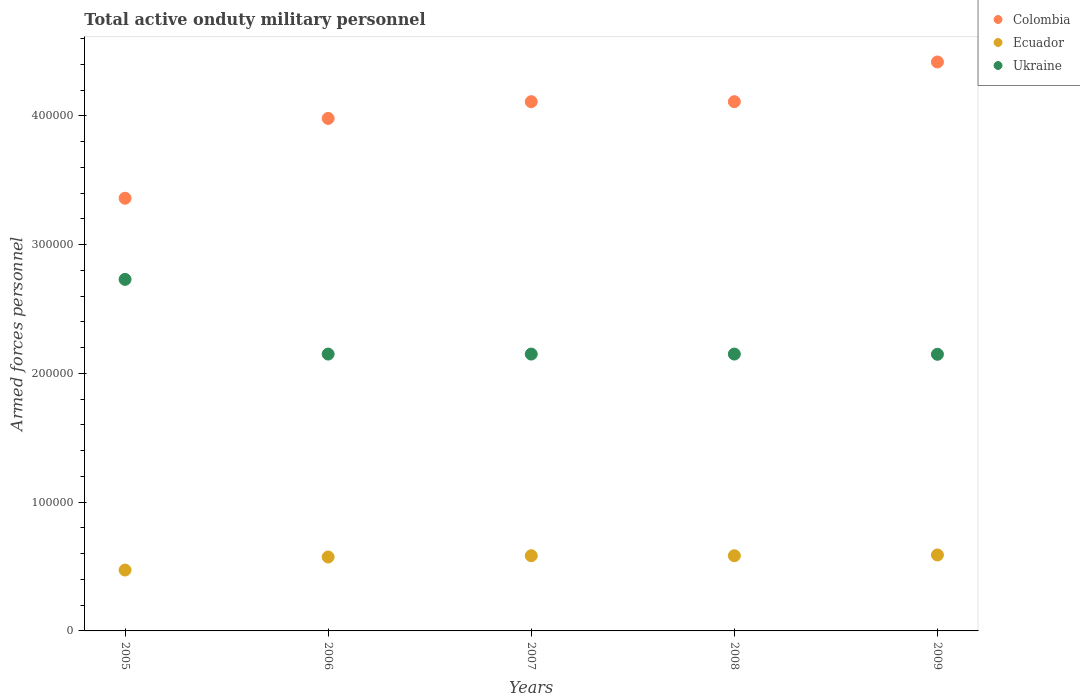Is the number of dotlines equal to the number of legend labels?
Give a very brief answer. Yes. What is the number of armed forces personnel in Ukraine in 2006?
Provide a succinct answer. 2.15e+05. Across all years, what is the maximum number of armed forces personnel in Ukraine?
Ensure brevity in your answer.  2.73e+05. Across all years, what is the minimum number of armed forces personnel in Ukraine?
Offer a terse response. 2.15e+05. What is the total number of armed forces personnel in Ecuador in the graph?
Offer a terse response. 2.80e+05. What is the difference between the number of armed forces personnel in Ecuador in 2006 and that in 2007?
Your answer should be very brief. -1000. What is the difference between the number of armed forces personnel in Colombia in 2005 and the number of armed forces personnel in Ecuador in 2009?
Ensure brevity in your answer.  2.77e+05. What is the average number of armed forces personnel in Ecuador per year?
Provide a succinct answer. 5.61e+04. In the year 2008, what is the difference between the number of armed forces personnel in Colombia and number of armed forces personnel in Ecuador?
Ensure brevity in your answer.  3.53e+05. What is the ratio of the number of armed forces personnel in Ukraine in 2006 to that in 2008?
Provide a short and direct response. 1. What is the difference between the highest and the second highest number of armed forces personnel in Ukraine?
Offer a terse response. 5.80e+04. What is the difference between the highest and the lowest number of armed forces personnel in Colombia?
Keep it short and to the point. 1.06e+05. Is the sum of the number of armed forces personnel in Ukraine in 2006 and 2009 greater than the maximum number of armed forces personnel in Ecuador across all years?
Give a very brief answer. Yes. Is it the case that in every year, the sum of the number of armed forces personnel in Ukraine and number of armed forces personnel in Ecuador  is greater than the number of armed forces personnel in Colombia?
Offer a terse response. No. Does the number of armed forces personnel in Colombia monotonically increase over the years?
Ensure brevity in your answer.  No. Is the number of armed forces personnel in Ecuador strictly less than the number of armed forces personnel in Colombia over the years?
Keep it short and to the point. Yes. How many years are there in the graph?
Give a very brief answer. 5. Are the values on the major ticks of Y-axis written in scientific E-notation?
Your answer should be compact. No. Does the graph contain any zero values?
Ensure brevity in your answer.  No. Does the graph contain grids?
Ensure brevity in your answer.  No. Where does the legend appear in the graph?
Give a very brief answer. Top right. What is the title of the graph?
Your response must be concise. Total active onduty military personnel. Does "Sudan" appear as one of the legend labels in the graph?
Your answer should be very brief. No. What is the label or title of the Y-axis?
Provide a short and direct response. Armed forces personnel. What is the Armed forces personnel in Colombia in 2005?
Give a very brief answer. 3.36e+05. What is the Armed forces personnel in Ecuador in 2005?
Your response must be concise. 4.73e+04. What is the Armed forces personnel of Ukraine in 2005?
Your answer should be compact. 2.73e+05. What is the Armed forces personnel of Colombia in 2006?
Provide a short and direct response. 3.98e+05. What is the Armed forces personnel of Ecuador in 2006?
Provide a succinct answer. 5.74e+04. What is the Armed forces personnel of Ukraine in 2006?
Ensure brevity in your answer.  2.15e+05. What is the Armed forces personnel of Colombia in 2007?
Provide a succinct answer. 4.11e+05. What is the Armed forces personnel in Ecuador in 2007?
Provide a succinct answer. 5.84e+04. What is the Armed forces personnel in Ukraine in 2007?
Provide a short and direct response. 2.15e+05. What is the Armed forces personnel of Colombia in 2008?
Give a very brief answer. 4.11e+05. What is the Armed forces personnel in Ecuador in 2008?
Offer a terse response. 5.84e+04. What is the Armed forces personnel in Ukraine in 2008?
Keep it short and to the point. 2.15e+05. What is the Armed forces personnel of Colombia in 2009?
Provide a succinct answer. 4.42e+05. What is the Armed forces personnel in Ecuador in 2009?
Offer a very short reply. 5.90e+04. What is the Armed forces personnel in Ukraine in 2009?
Your response must be concise. 2.15e+05. Across all years, what is the maximum Armed forces personnel of Colombia?
Your response must be concise. 4.42e+05. Across all years, what is the maximum Armed forces personnel of Ecuador?
Ensure brevity in your answer.  5.90e+04. Across all years, what is the maximum Armed forces personnel of Ukraine?
Ensure brevity in your answer.  2.73e+05. Across all years, what is the minimum Armed forces personnel of Colombia?
Your answer should be compact. 3.36e+05. Across all years, what is the minimum Armed forces personnel in Ecuador?
Keep it short and to the point. 4.73e+04. Across all years, what is the minimum Armed forces personnel of Ukraine?
Keep it short and to the point. 2.15e+05. What is the total Armed forces personnel of Colombia in the graph?
Provide a short and direct response. 2.00e+06. What is the total Armed forces personnel of Ecuador in the graph?
Make the answer very short. 2.80e+05. What is the total Armed forces personnel of Ukraine in the graph?
Make the answer very short. 1.13e+06. What is the difference between the Armed forces personnel in Colombia in 2005 and that in 2006?
Offer a very short reply. -6.20e+04. What is the difference between the Armed forces personnel of Ecuador in 2005 and that in 2006?
Make the answer very short. -1.01e+04. What is the difference between the Armed forces personnel in Ukraine in 2005 and that in 2006?
Give a very brief answer. 5.80e+04. What is the difference between the Armed forces personnel in Colombia in 2005 and that in 2007?
Keep it short and to the point. -7.50e+04. What is the difference between the Armed forces personnel in Ecuador in 2005 and that in 2007?
Your answer should be very brief. -1.11e+04. What is the difference between the Armed forces personnel in Ukraine in 2005 and that in 2007?
Your response must be concise. 5.80e+04. What is the difference between the Armed forces personnel in Colombia in 2005 and that in 2008?
Keep it short and to the point. -7.50e+04. What is the difference between the Armed forces personnel of Ecuador in 2005 and that in 2008?
Make the answer very short. -1.11e+04. What is the difference between the Armed forces personnel in Ukraine in 2005 and that in 2008?
Give a very brief answer. 5.80e+04. What is the difference between the Armed forces personnel in Colombia in 2005 and that in 2009?
Provide a short and direct response. -1.06e+05. What is the difference between the Armed forces personnel in Ecuador in 2005 and that in 2009?
Ensure brevity in your answer.  -1.17e+04. What is the difference between the Armed forces personnel in Ukraine in 2005 and that in 2009?
Provide a succinct answer. 5.82e+04. What is the difference between the Armed forces personnel in Colombia in 2006 and that in 2007?
Provide a succinct answer. -1.30e+04. What is the difference between the Armed forces personnel in Ecuador in 2006 and that in 2007?
Offer a very short reply. -1000. What is the difference between the Armed forces personnel in Ukraine in 2006 and that in 2007?
Give a very brief answer. 0. What is the difference between the Armed forces personnel of Colombia in 2006 and that in 2008?
Ensure brevity in your answer.  -1.30e+04. What is the difference between the Armed forces personnel in Ecuador in 2006 and that in 2008?
Make the answer very short. -1000. What is the difference between the Armed forces personnel in Colombia in 2006 and that in 2009?
Ensure brevity in your answer.  -4.38e+04. What is the difference between the Armed forces personnel of Ecuador in 2006 and that in 2009?
Your response must be concise. -1583. What is the difference between the Armed forces personnel of Ukraine in 2006 and that in 2009?
Provide a succinct answer. 175. What is the difference between the Armed forces personnel in Colombia in 2007 and that in 2008?
Give a very brief answer. 0. What is the difference between the Armed forces personnel in Ukraine in 2007 and that in 2008?
Keep it short and to the point. 0. What is the difference between the Armed forces personnel in Colombia in 2007 and that in 2009?
Your answer should be very brief. -3.08e+04. What is the difference between the Armed forces personnel of Ecuador in 2007 and that in 2009?
Keep it short and to the point. -583. What is the difference between the Armed forces personnel of Ukraine in 2007 and that in 2009?
Ensure brevity in your answer.  175. What is the difference between the Armed forces personnel of Colombia in 2008 and that in 2009?
Your answer should be very brief. -3.08e+04. What is the difference between the Armed forces personnel in Ecuador in 2008 and that in 2009?
Your answer should be compact. -583. What is the difference between the Armed forces personnel in Ukraine in 2008 and that in 2009?
Your response must be concise. 175. What is the difference between the Armed forces personnel of Colombia in 2005 and the Armed forces personnel of Ecuador in 2006?
Your answer should be very brief. 2.79e+05. What is the difference between the Armed forces personnel in Colombia in 2005 and the Armed forces personnel in Ukraine in 2006?
Offer a terse response. 1.21e+05. What is the difference between the Armed forces personnel of Ecuador in 2005 and the Armed forces personnel of Ukraine in 2006?
Keep it short and to the point. -1.68e+05. What is the difference between the Armed forces personnel in Colombia in 2005 and the Armed forces personnel in Ecuador in 2007?
Keep it short and to the point. 2.78e+05. What is the difference between the Armed forces personnel in Colombia in 2005 and the Armed forces personnel in Ukraine in 2007?
Give a very brief answer. 1.21e+05. What is the difference between the Armed forces personnel in Ecuador in 2005 and the Armed forces personnel in Ukraine in 2007?
Your answer should be compact. -1.68e+05. What is the difference between the Armed forces personnel in Colombia in 2005 and the Armed forces personnel in Ecuador in 2008?
Give a very brief answer. 2.78e+05. What is the difference between the Armed forces personnel of Colombia in 2005 and the Armed forces personnel of Ukraine in 2008?
Offer a terse response. 1.21e+05. What is the difference between the Armed forces personnel in Ecuador in 2005 and the Armed forces personnel in Ukraine in 2008?
Keep it short and to the point. -1.68e+05. What is the difference between the Armed forces personnel in Colombia in 2005 and the Armed forces personnel in Ecuador in 2009?
Provide a succinct answer. 2.77e+05. What is the difference between the Armed forces personnel of Colombia in 2005 and the Armed forces personnel of Ukraine in 2009?
Offer a very short reply. 1.21e+05. What is the difference between the Armed forces personnel of Ecuador in 2005 and the Armed forces personnel of Ukraine in 2009?
Your answer should be compact. -1.68e+05. What is the difference between the Armed forces personnel of Colombia in 2006 and the Armed forces personnel of Ecuador in 2007?
Your answer should be very brief. 3.40e+05. What is the difference between the Armed forces personnel in Colombia in 2006 and the Armed forces personnel in Ukraine in 2007?
Offer a terse response. 1.83e+05. What is the difference between the Armed forces personnel of Ecuador in 2006 and the Armed forces personnel of Ukraine in 2007?
Your answer should be very brief. -1.58e+05. What is the difference between the Armed forces personnel of Colombia in 2006 and the Armed forces personnel of Ecuador in 2008?
Provide a succinct answer. 3.40e+05. What is the difference between the Armed forces personnel of Colombia in 2006 and the Armed forces personnel of Ukraine in 2008?
Your response must be concise. 1.83e+05. What is the difference between the Armed forces personnel of Ecuador in 2006 and the Armed forces personnel of Ukraine in 2008?
Your response must be concise. -1.58e+05. What is the difference between the Armed forces personnel of Colombia in 2006 and the Armed forces personnel of Ecuador in 2009?
Offer a very short reply. 3.39e+05. What is the difference between the Armed forces personnel of Colombia in 2006 and the Armed forces personnel of Ukraine in 2009?
Ensure brevity in your answer.  1.83e+05. What is the difference between the Armed forces personnel in Ecuador in 2006 and the Armed forces personnel in Ukraine in 2009?
Provide a succinct answer. -1.57e+05. What is the difference between the Armed forces personnel in Colombia in 2007 and the Armed forces personnel in Ecuador in 2008?
Your answer should be very brief. 3.53e+05. What is the difference between the Armed forces personnel of Colombia in 2007 and the Armed forces personnel of Ukraine in 2008?
Offer a terse response. 1.96e+05. What is the difference between the Armed forces personnel in Ecuador in 2007 and the Armed forces personnel in Ukraine in 2008?
Your answer should be very brief. -1.57e+05. What is the difference between the Armed forces personnel in Colombia in 2007 and the Armed forces personnel in Ecuador in 2009?
Offer a terse response. 3.52e+05. What is the difference between the Armed forces personnel in Colombia in 2007 and the Armed forces personnel in Ukraine in 2009?
Keep it short and to the point. 1.96e+05. What is the difference between the Armed forces personnel in Ecuador in 2007 and the Armed forces personnel in Ukraine in 2009?
Provide a succinct answer. -1.56e+05. What is the difference between the Armed forces personnel of Colombia in 2008 and the Armed forces personnel of Ecuador in 2009?
Your answer should be very brief. 3.52e+05. What is the difference between the Armed forces personnel in Colombia in 2008 and the Armed forces personnel in Ukraine in 2009?
Ensure brevity in your answer.  1.96e+05. What is the difference between the Armed forces personnel in Ecuador in 2008 and the Armed forces personnel in Ukraine in 2009?
Keep it short and to the point. -1.56e+05. What is the average Armed forces personnel in Colombia per year?
Provide a succinct answer. 4.00e+05. What is the average Armed forces personnel in Ecuador per year?
Your answer should be very brief. 5.61e+04. What is the average Armed forces personnel of Ukraine per year?
Make the answer very short. 2.27e+05. In the year 2005, what is the difference between the Armed forces personnel of Colombia and Armed forces personnel of Ecuador?
Make the answer very short. 2.89e+05. In the year 2005, what is the difference between the Armed forces personnel in Colombia and Armed forces personnel in Ukraine?
Offer a very short reply. 6.30e+04. In the year 2005, what is the difference between the Armed forces personnel of Ecuador and Armed forces personnel of Ukraine?
Offer a very short reply. -2.26e+05. In the year 2006, what is the difference between the Armed forces personnel in Colombia and Armed forces personnel in Ecuador?
Provide a succinct answer. 3.41e+05. In the year 2006, what is the difference between the Armed forces personnel of Colombia and Armed forces personnel of Ukraine?
Offer a terse response. 1.83e+05. In the year 2006, what is the difference between the Armed forces personnel in Ecuador and Armed forces personnel in Ukraine?
Provide a short and direct response. -1.58e+05. In the year 2007, what is the difference between the Armed forces personnel in Colombia and Armed forces personnel in Ecuador?
Offer a terse response. 3.53e+05. In the year 2007, what is the difference between the Armed forces personnel of Colombia and Armed forces personnel of Ukraine?
Your answer should be very brief. 1.96e+05. In the year 2007, what is the difference between the Armed forces personnel in Ecuador and Armed forces personnel in Ukraine?
Ensure brevity in your answer.  -1.57e+05. In the year 2008, what is the difference between the Armed forces personnel of Colombia and Armed forces personnel of Ecuador?
Your answer should be compact. 3.53e+05. In the year 2008, what is the difference between the Armed forces personnel of Colombia and Armed forces personnel of Ukraine?
Offer a terse response. 1.96e+05. In the year 2008, what is the difference between the Armed forces personnel of Ecuador and Armed forces personnel of Ukraine?
Provide a short and direct response. -1.57e+05. In the year 2009, what is the difference between the Armed forces personnel in Colombia and Armed forces personnel in Ecuador?
Provide a succinct answer. 3.83e+05. In the year 2009, what is the difference between the Armed forces personnel in Colombia and Armed forces personnel in Ukraine?
Keep it short and to the point. 2.27e+05. In the year 2009, what is the difference between the Armed forces personnel in Ecuador and Armed forces personnel in Ukraine?
Provide a succinct answer. -1.56e+05. What is the ratio of the Armed forces personnel in Colombia in 2005 to that in 2006?
Provide a short and direct response. 0.84. What is the ratio of the Armed forces personnel in Ecuador in 2005 to that in 2006?
Provide a short and direct response. 0.82. What is the ratio of the Armed forces personnel in Ukraine in 2005 to that in 2006?
Make the answer very short. 1.27. What is the ratio of the Armed forces personnel of Colombia in 2005 to that in 2007?
Your answer should be very brief. 0.82. What is the ratio of the Armed forces personnel in Ecuador in 2005 to that in 2007?
Your answer should be very brief. 0.81. What is the ratio of the Armed forces personnel of Ukraine in 2005 to that in 2007?
Ensure brevity in your answer.  1.27. What is the ratio of the Armed forces personnel in Colombia in 2005 to that in 2008?
Your answer should be very brief. 0.82. What is the ratio of the Armed forces personnel in Ecuador in 2005 to that in 2008?
Ensure brevity in your answer.  0.81. What is the ratio of the Armed forces personnel of Ukraine in 2005 to that in 2008?
Offer a terse response. 1.27. What is the ratio of the Armed forces personnel of Colombia in 2005 to that in 2009?
Make the answer very short. 0.76. What is the ratio of the Armed forces personnel of Ecuador in 2005 to that in 2009?
Make the answer very short. 0.8. What is the ratio of the Armed forces personnel of Ukraine in 2005 to that in 2009?
Provide a succinct answer. 1.27. What is the ratio of the Armed forces personnel in Colombia in 2006 to that in 2007?
Offer a very short reply. 0.97. What is the ratio of the Armed forces personnel in Ecuador in 2006 to that in 2007?
Your response must be concise. 0.98. What is the ratio of the Armed forces personnel of Colombia in 2006 to that in 2008?
Provide a succinct answer. 0.97. What is the ratio of the Armed forces personnel of Ecuador in 2006 to that in 2008?
Provide a succinct answer. 0.98. What is the ratio of the Armed forces personnel of Ukraine in 2006 to that in 2008?
Offer a terse response. 1. What is the ratio of the Armed forces personnel in Colombia in 2006 to that in 2009?
Provide a short and direct response. 0.9. What is the ratio of the Armed forces personnel in Ecuador in 2006 to that in 2009?
Your response must be concise. 0.97. What is the ratio of the Armed forces personnel of Colombia in 2007 to that in 2009?
Provide a short and direct response. 0.93. What is the ratio of the Armed forces personnel in Ecuador in 2007 to that in 2009?
Provide a succinct answer. 0.99. What is the ratio of the Armed forces personnel in Colombia in 2008 to that in 2009?
Offer a very short reply. 0.93. What is the ratio of the Armed forces personnel in Ukraine in 2008 to that in 2009?
Your answer should be very brief. 1. What is the difference between the highest and the second highest Armed forces personnel in Colombia?
Ensure brevity in your answer.  3.08e+04. What is the difference between the highest and the second highest Armed forces personnel of Ecuador?
Ensure brevity in your answer.  583. What is the difference between the highest and the second highest Armed forces personnel in Ukraine?
Give a very brief answer. 5.80e+04. What is the difference between the highest and the lowest Armed forces personnel in Colombia?
Give a very brief answer. 1.06e+05. What is the difference between the highest and the lowest Armed forces personnel in Ecuador?
Ensure brevity in your answer.  1.17e+04. What is the difference between the highest and the lowest Armed forces personnel of Ukraine?
Your response must be concise. 5.82e+04. 